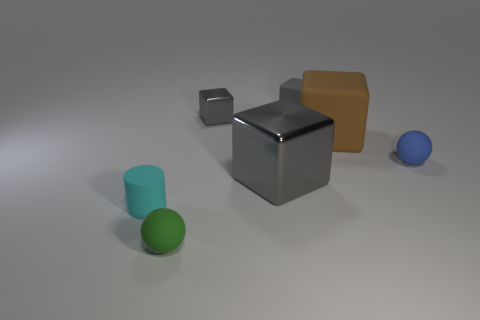Are there an equal number of cyan rubber objects behind the blue sphere and blue rubber spheres?
Ensure brevity in your answer.  No. What number of objects are either green shiny balls or cylinders?
Offer a terse response. 1. Are there any other things that have the same shape as the large gray object?
Ensure brevity in your answer.  Yes. What shape is the rubber thing that is on the left side of the ball that is in front of the cyan cylinder?
Your response must be concise. Cylinder. What shape is the green thing that is the same material as the tiny cyan cylinder?
Your answer should be compact. Sphere. There is a gray matte object on the left side of the sphere behind the green rubber thing; what is its size?
Ensure brevity in your answer.  Small. The small blue matte object is what shape?
Your answer should be very brief. Sphere. What number of small objects are either gray things or gray metal blocks?
Provide a succinct answer. 2. There is a brown matte object that is the same shape as the tiny gray rubber object; what is its size?
Offer a very short reply. Large. What number of tiny balls are both on the right side of the tiny green sphere and to the left of the blue ball?
Ensure brevity in your answer.  0. 